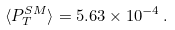<formula> <loc_0><loc_0><loc_500><loc_500>\langle P _ { T } ^ { S M } \rangle = 5 . 6 3 \times 1 0 ^ { - 4 } \, .</formula> 